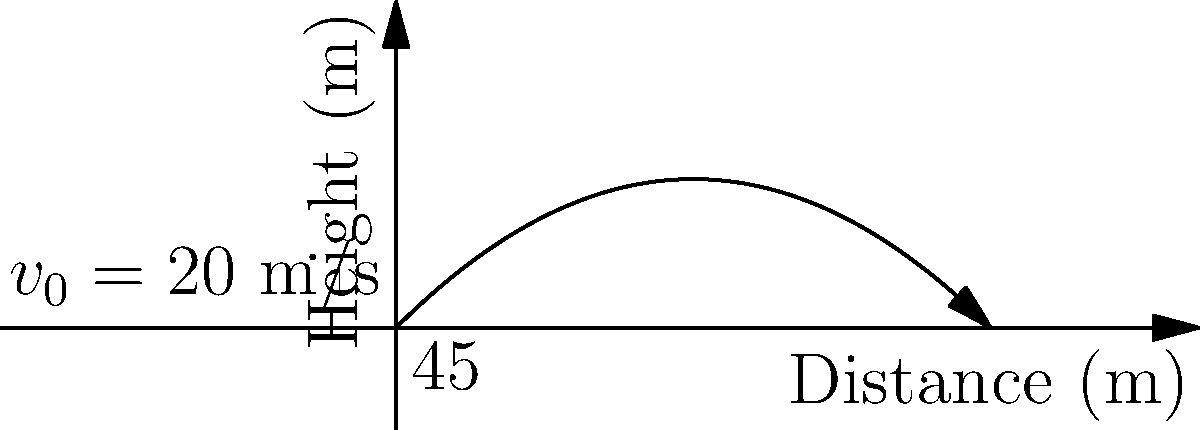Your daughter is working on a physics project about projectile motion. She launches a ball from ground level at an initial velocity of 20 m/s and an angle of 45° to the horizontal. Assuming air resistance is negligible, what is the maximum height reached by the ball? Let's approach this step-by-step:

1) The maximum height is reached when the vertical component of velocity becomes zero.

2) We can use the equation: $v_y = v_0 \sin \theta - gt$, where:
   $v_y$ is the vertical component of velocity
   $v_0$ is the initial velocity (20 m/s)
   $\theta$ is the launch angle (45°)
   $g$ is the acceleration due to gravity (9.8 m/s²)
   $t$ is the time

3) At maximum height, $v_y = 0$, so:
   $0 = v_0 \sin \theta - gt_{\text{max}}$

4) Solving for $t_{\text{max}}$:
   $t_{\text{max}} = \frac{v_0 \sin \theta}{g} = \frac{20 \sin 45°}{9.8} \approx 1.44$ s

5) Now we can use the equation for height: $y = v_0 \sin \theta \cdot t - \frac{1}{2}gt^2$

6) Substituting $t_{\text{max}}$:
   $y_{\text{max}} = v_0 \sin \theta \cdot (\frac{v_0 \sin \theta}{g}) - \frac{1}{2}g(\frac{v_0 \sin \theta}{g})^2$

7) Simplifying:
   $y_{\text{max}} = \frac{(v_0 \sin \theta)^2}{2g}$

8) Plugging in the values:
   $y_{\text{max}} = \frac{(20 \sin 45°)^2}{2(9.8)} \approx 10.2$ m

Therefore, the maximum height reached by the ball is approximately 10.2 meters.
Answer: 10.2 m 